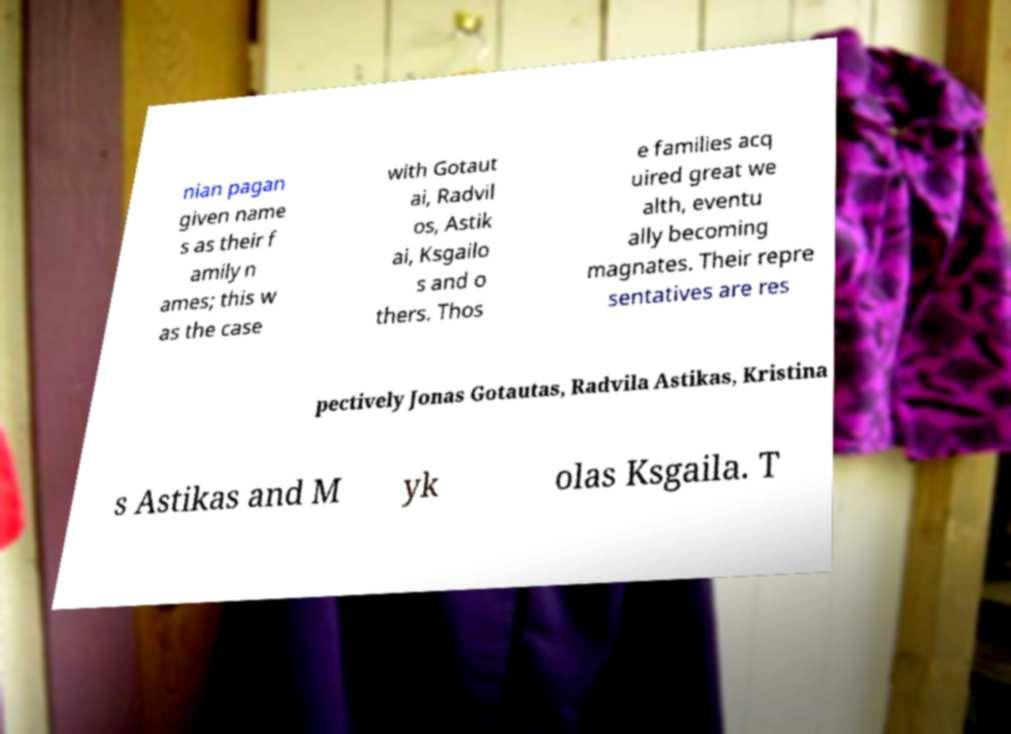Could you extract and type out the text from this image? nian pagan given name s as their f amily n ames; this w as the case with Gotaut ai, Radvil os, Astik ai, Ksgailo s and o thers. Thos e families acq uired great we alth, eventu ally becoming magnates. Their repre sentatives are res pectively Jonas Gotautas, Radvila Astikas, Kristina s Astikas and M yk olas Ksgaila. T 